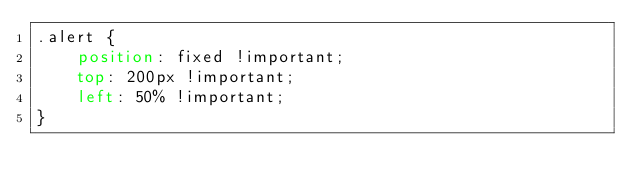<code> <loc_0><loc_0><loc_500><loc_500><_CSS_>.alert {
    position: fixed !important;
    top: 200px !important;
    left: 50% !important;
}
</code> 